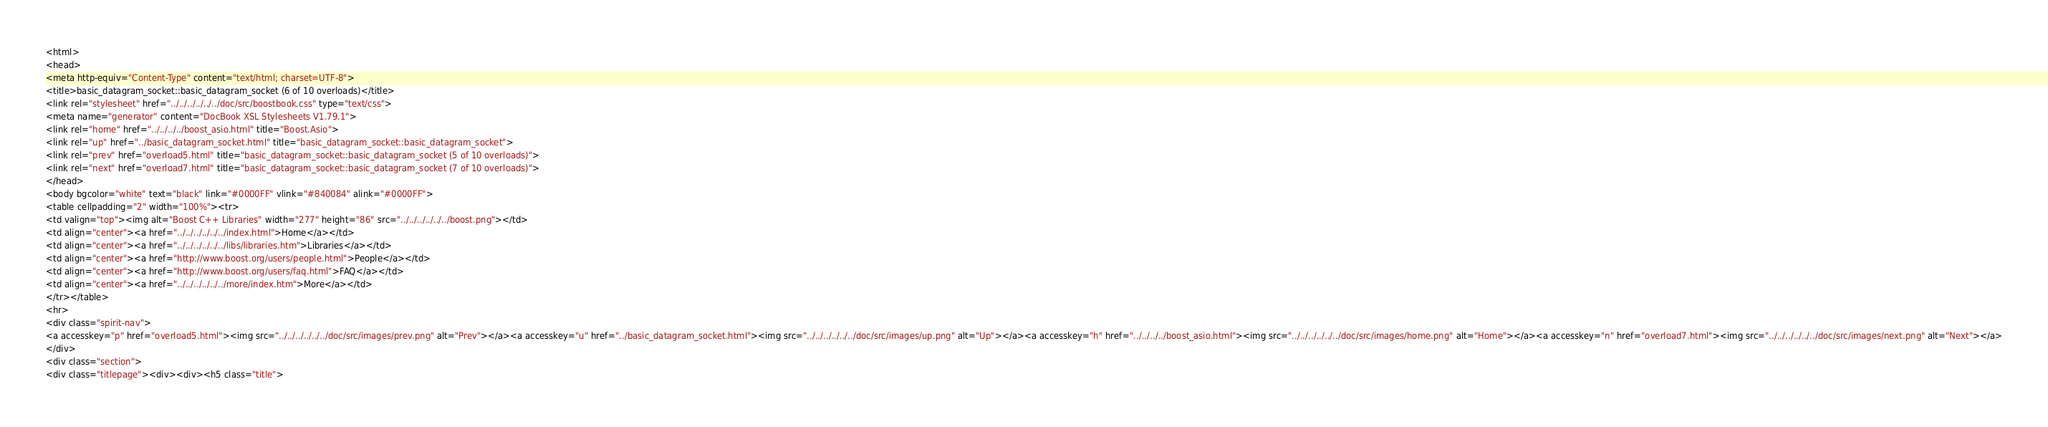<code> <loc_0><loc_0><loc_500><loc_500><_HTML_><html>
<head>
<meta http-equiv="Content-Type" content="text/html; charset=UTF-8">
<title>basic_datagram_socket::basic_datagram_socket (6 of 10 overloads)</title>
<link rel="stylesheet" href="../../../../../../doc/src/boostbook.css" type="text/css">
<meta name="generator" content="DocBook XSL Stylesheets V1.79.1">
<link rel="home" href="../../../../boost_asio.html" title="Boost.Asio">
<link rel="up" href="../basic_datagram_socket.html" title="basic_datagram_socket::basic_datagram_socket">
<link rel="prev" href="overload5.html" title="basic_datagram_socket::basic_datagram_socket (5 of 10 overloads)">
<link rel="next" href="overload7.html" title="basic_datagram_socket::basic_datagram_socket (7 of 10 overloads)">
</head>
<body bgcolor="white" text="black" link="#0000FF" vlink="#840084" alink="#0000FF">
<table cellpadding="2" width="100%"><tr>
<td valign="top"><img alt="Boost C++ Libraries" width="277" height="86" src="../../../../../../boost.png"></td>
<td align="center"><a href="../../../../../../index.html">Home</a></td>
<td align="center"><a href="../../../../../../libs/libraries.htm">Libraries</a></td>
<td align="center"><a href="http://www.boost.org/users/people.html">People</a></td>
<td align="center"><a href="http://www.boost.org/users/faq.html">FAQ</a></td>
<td align="center"><a href="../../../../../../more/index.htm">More</a></td>
</tr></table>
<hr>
<div class="spirit-nav">
<a accesskey="p" href="overload5.html"><img src="../../../../../../doc/src/images/prev.png" alt="Prev"></a><a accesskey="u" href="../basic_datagram_socket.html"><img src="../../../../../../doc/src/images/up.png" alt="Up"></a><a accesskey="h" href="../../../../boost_asio.html"><img src="../../../../../../doc/src/images/home.png" alt="Home"></a><a accesskey="n" href="overload7.html"><img src="../../../../../../doc/src/images/next.png" alt="Next"></a>
</div>
<div class="section">
<div class="titlepage"><div><div><h5 class="title"></code> 